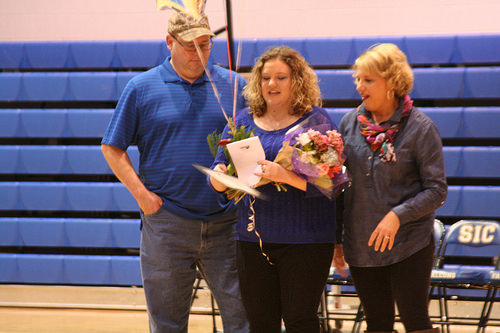<image>
Is the woman to the left of the man? Yes. From this viewpoint, the woman is positioned to the left side relative to the man. 